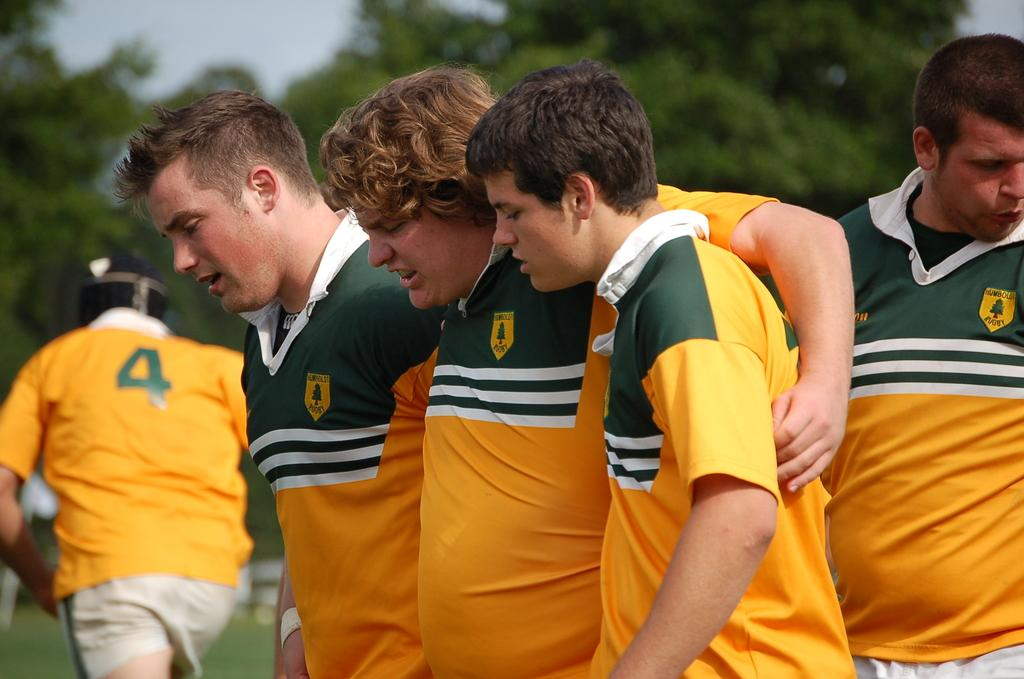Provide a one-sentence caption for the provided image. young men in green and yellow RUGBY shirts one with a number 4 on it. 